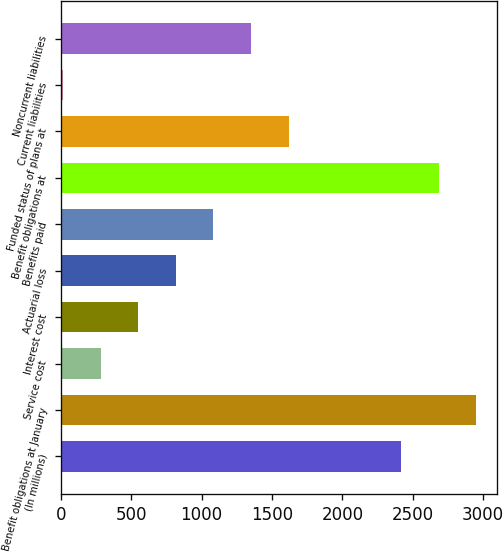<chart> <loc_0><loc_0><loc_500><loc_500><bar_chart><fcel>(In millions)<fcel>Benefit obligations at January<fcel>Service cost<fcel>Interest cost<fcel>Actuarial loss<fcel>Benefits paid<fcel>Benefit obligations at<fcel>Funded status of plans at<fcel>Current liabilities<fcel>Noncurrent liabilities<nl><fcel>2418.3<fcel>2951.7<fcel>284.7<fcel>551.4<fcel>818.1<fcel>1084.8<fcel>2685<fcel>1618.2<fcel>18<fcel>1351.5<nl></chart> 